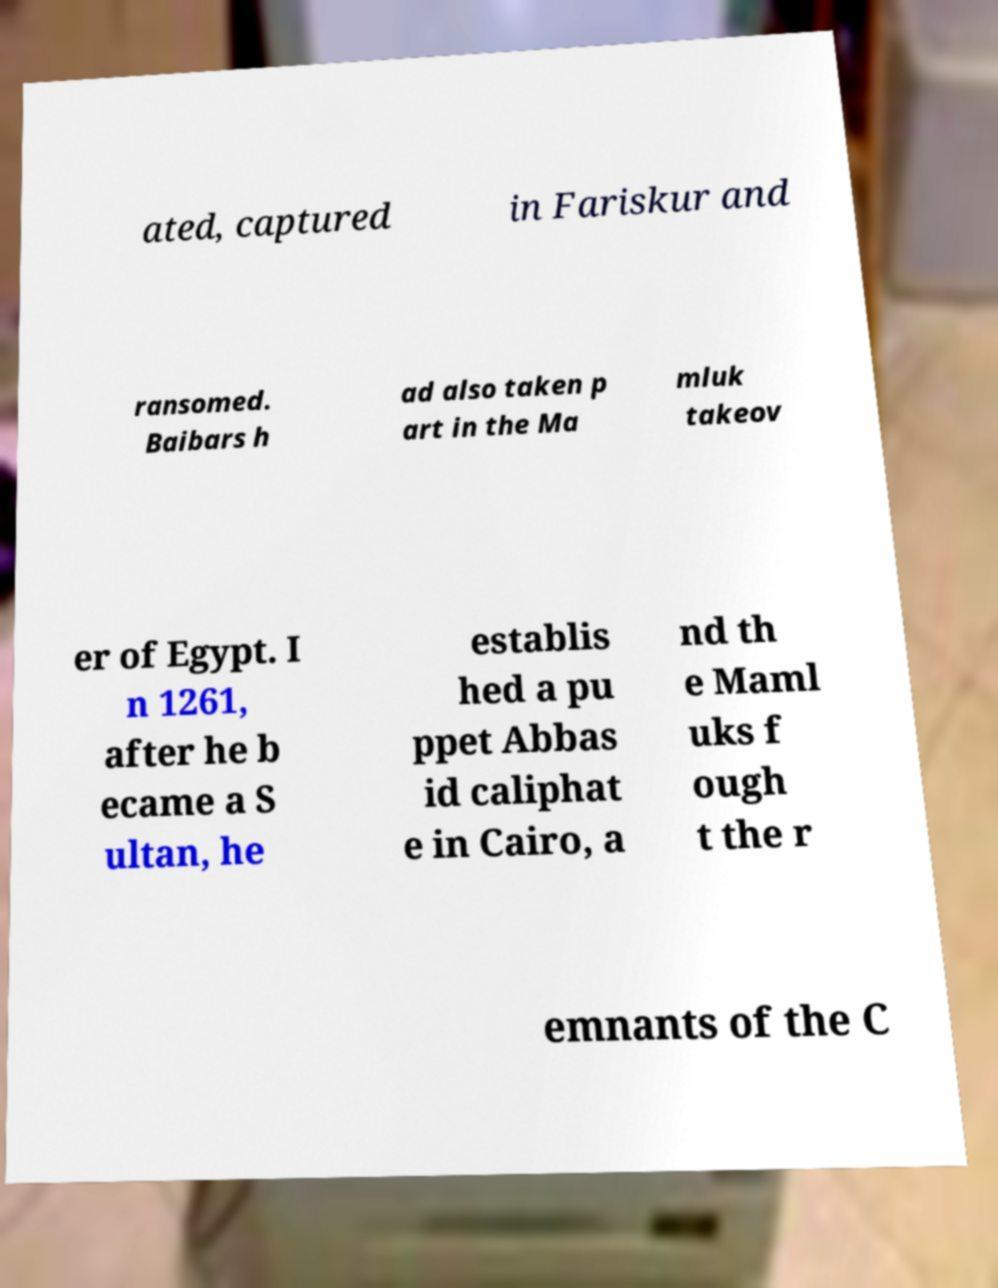Can you accurately transcribe the text from the provided image for me? ated, captured in Fariskur and ransomed. Baibars h ad also taken p art in the Ma mluk takeov er of Egypt. I n 1261, after he b ecame a S ultan, he establis hed a pu ppet Abbas id caliphat e in Cairo, a nd th e Maml uks f ough t the r emnants of the C 